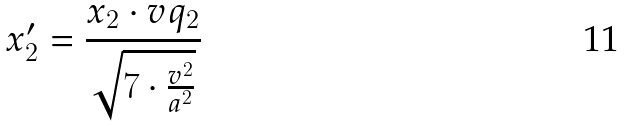<formula> <loc_0><loc_0><loc_500><loc_500>x _ { 2 } ^ { \prime } = \frac { x _ { 2 } \cdot v q _ { 2 } } { \sqrt { 7 \cdot \frac { v ^ { 2 } } { a ^ { 2 } } } }</formula> 